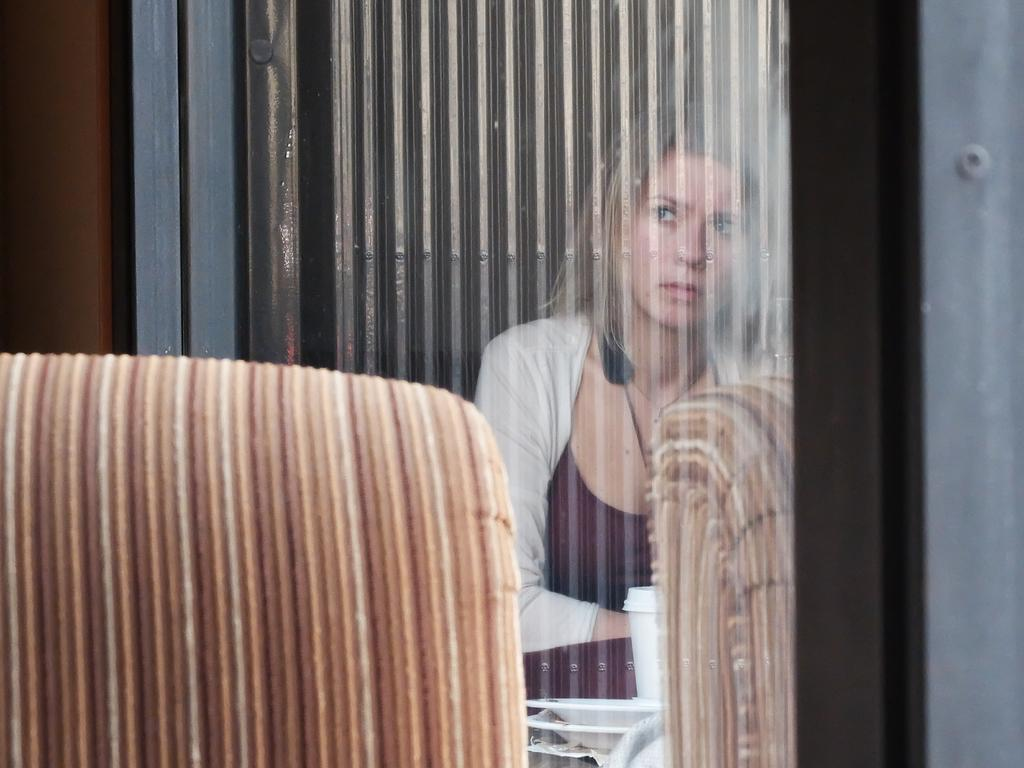What can be seen in the window glass in the image? There is a reflection of a woman, a cup, and a few plates in the window glass. What else is visible in the window glass? There is a table visible in the window glass. Can you describe the furniture on the left side of the image? There appears to be a chair on the left side of the image. What type of insect is crawling on the competition in the image? There is no insect or competition present in the image. What liquid is being poured into the cup in the image? There is no liquid being poured into the cup in the image; it is already present in the reflection. 